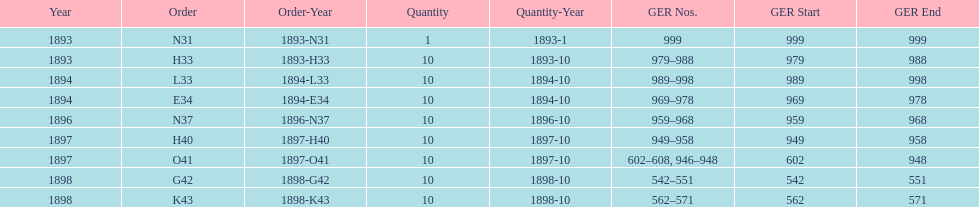Write the full table. {'header': ['Year', 'Order', 'Order-Year', 'Quantity', 'Quantity-Year', 'GER Nos.', 'GER Start', 'GER End'], 'rows': [['1893', 'N31', '1893-N31', '1', '1893-1', '999', '999', '999'], ['1893', 'H33', '1893-H33', '10', '1893-10', '979–988', '979', '988'], ['1894', 'L33', '1894-L33', '10', '1894-10', '989–998', '989', '998'], ['1894', 'E34', '1894-E34', '10', '1894-10', '969–978', '969', '978'], ['1896', 'N37', '1896-N37', '10', '1896-10', '959–968', '959', '968'], ['1897', 'H40', '1897-H40', '10', '1897-10', '949–958', '949', '958'], ['1897', 'O41', '1897-O41', '10', '1897-10', '602–608, 946–948', '602', '948'], ['1898', 'G42', '1898-G42', '10', '1898-10', '542–551', '542', '551'], ['1898', 'K43', '1898-K43', '10', '1898-10', '562–571', '562', '571']]} Which order was the next order after l33? E34. 